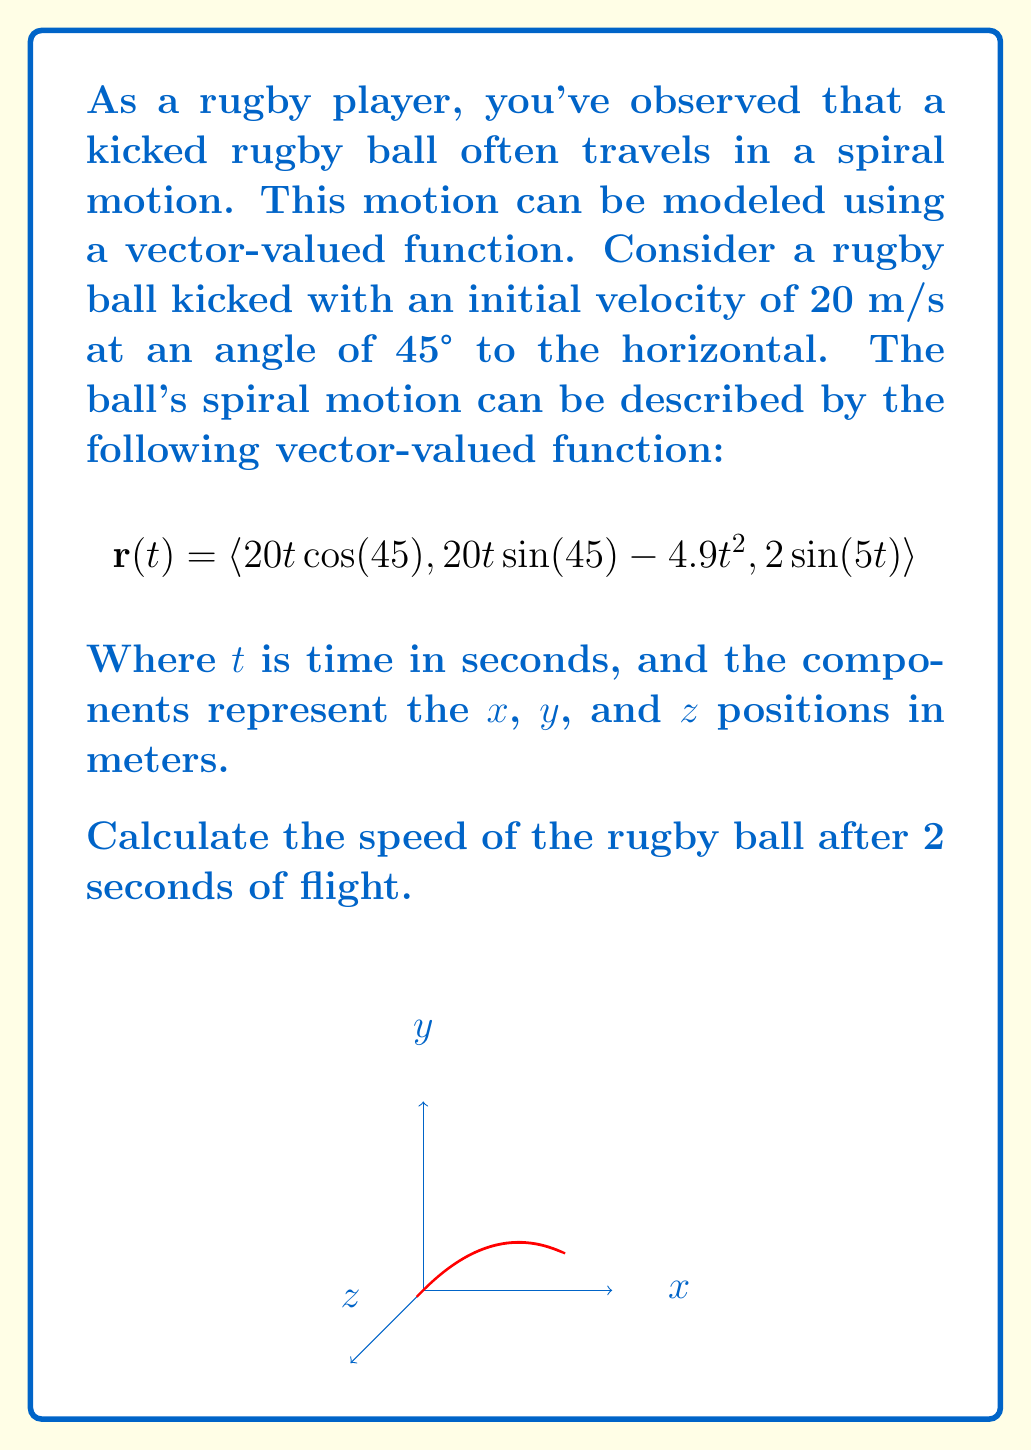Teach me how to tackle this problem. To find the speed of the rugby ball after 2 seconds, we need to calculate the magnitude of the velocity vector at $t=2$. Let's approach this step-by-step:

1) The velocity vector is the derivative of the position vector:
   $$\mathbf{v}(t) = \frac{d}{dt}\mathbf{r}(t) = \langle 20\cos(45°), 20\sin(45°) - 9.8t, 10\cos(5t) \rangle$$

2) At $t=2$:
   $$\mathbf{v}(2) = \langle 20\cos(45°), 20\sin(45°) - 19.6, 10\cos(10) \rangle$$

3) Calculate the components:
   - $20\cos(45°) \approx 14.14$ m/s
   - $20\sin(45°) - 19.6 \approx -5.46$ m/s
   - $10\cos(10) \approx -8.39$ m/s

4) The velocity vector at $t=2$ is:
   $$\mathbf{v}(2) \approx \langle 14.14, -5.46, -8.39 \rangle$$

5) The speed is the magnitude of the velocity vector:
   $$\text{speed} = \|\mathbf{v}(2)\| = \sqrt{(14.14)^2 + (-5.46)^2 + (-8.39)^2}$$

6) Calculate:
   $$\text{speed} \approx \sqrt{200.14 + 29.81 + 70.39} = \sqrt{300.34} \approx 17.33$$

Therefore, the speed of the rugby ball after 2 seconds is approximately 17.33 m/s.
Answer: 17.33 m/s 